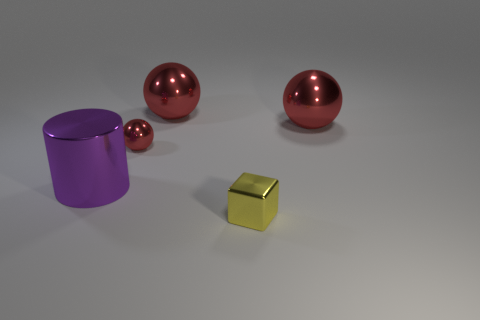What number of other things are there of the same material as the yellow thing? The yellow object appears metallic and reflective. There are four other objects in the image that display a similar metallic sheen and reflective quality, suggesting that they are made of the same or similar material. 